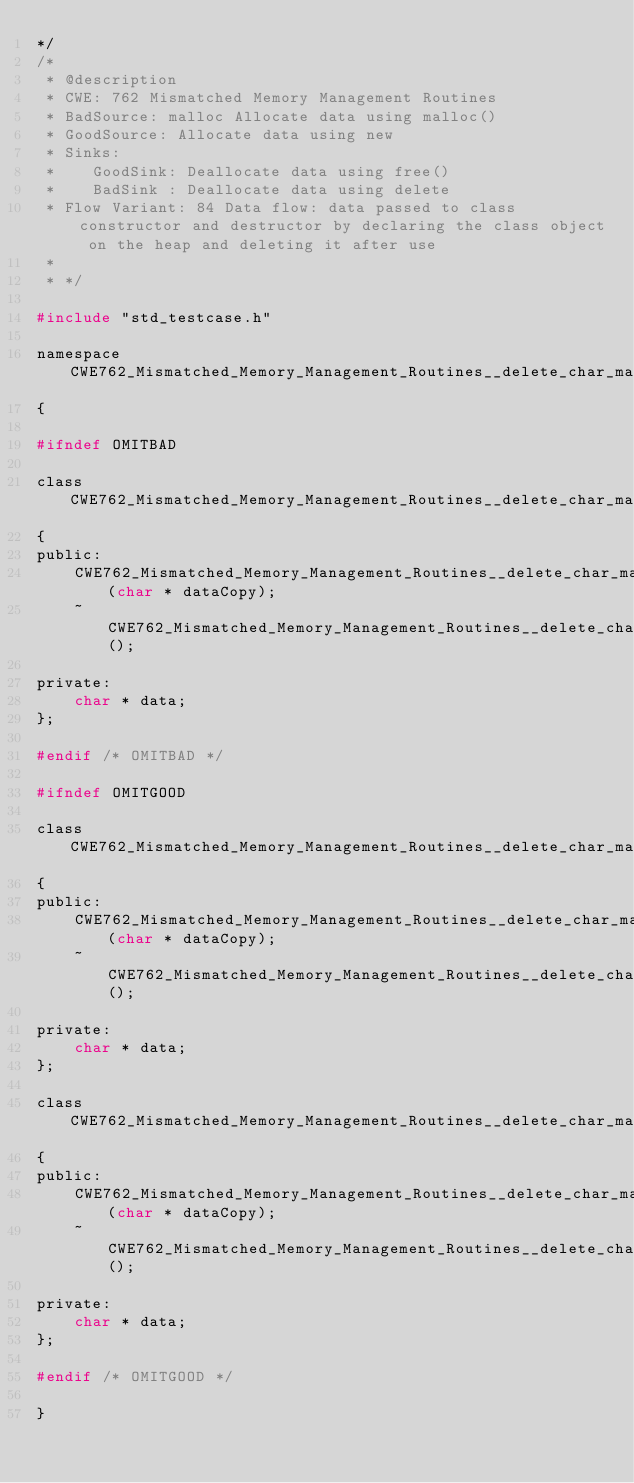<code> <loc_0><loc_0><loc_500><loc_500><_C_>*/
/*
 * @description
 * CWE: 762 Mismatched Memory Management Routines
 * BadSource: malloc Allocate data using malloc()
 * GoodSource: Allocate data using new
 * Sinks:
 *    GoodSink: Deallocate data using free()
 *    BadSink : Deallocate data using delete
 * Flow Variant: 84 Data flow: data passed to class constructor and destructor by declaring the class object on the heap and deleting it after use
 *
 * */

#include "std_testcase.h"

namespace CWE762_Mismatched_Memory_Management_Routines__delete_char_malloc_84
{

#ifndef OMITBAD

class CWE762_Mismatched_Memory_Management_Routines__delete_char_malloc_84_bad
{
public:
    CWE762_Mismatched_Memory_Management_Routines__delete_char_malloc_84_bad(char * dataCopy);
    ~CWE762_Mismatched_Memory_Management_Routines__delete_char_malloc_84_bad();

private:
    char * data;
};

#endif /* OMITBAD */

#ifndef OMITGOOD

class CWE762_Mismatched_Memory_Management_Routines__delete_char_malloc_84_goodG2B
{
public:
    CWE762_Mismatched_Memory_Management_Routines__delete_char_malloc_84_goodG2B(char * dataCopy);
    ~CWE762_Mismatched_Memory_Management_Routines__delete_char_malloc_84_goodG2B();

private:
    char * data;
};

class CWE762_Mismatched_Memory_Management_Routines__delete_char_malloc_84_goodB2G
{
public:
    CWE762_Mismatched_Memory_Management_Routines__delete_char_malloc_84_goodB2G(char * dataCopy);
    ~CWE762_Mismatched_Memory_Management_Routines__delete_char_malloc_84_goodB2G();

private:
    char * data;
};

#endif /* OMITGOOD */

}
</code> 